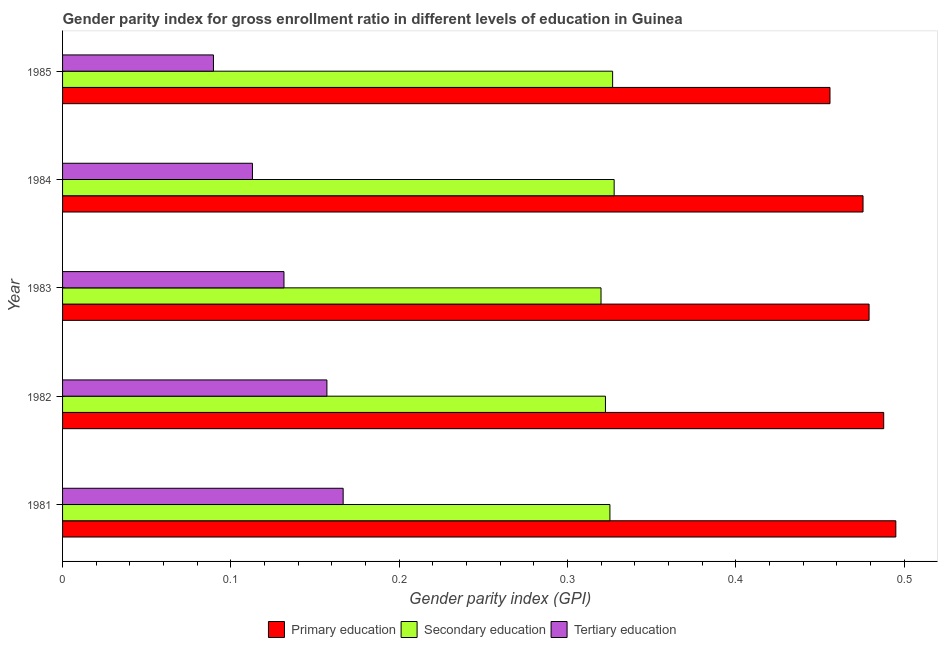How many groups of bars are there?
Offer a very short reply. 5. Are the number of bars per tick equal to the number of legend labels?
Your response must be concise. Yes. How many bars are there on the 3rd tick from the bottom?
Offer a very short reply. 3. In how many cases, is the number of bars for a given year not equal to the number of legend labels?
Give a very brief answer. 0. What is the gender parity index in secondary education in 1985?
Ensure brevity in your answer.  0.33. Across all years, what is the maximum gender parity index in secondary education?
Give a very brief answer. 0.33. Across all years, what is the minimum gender parity index in secondary education?
Provide a short and direct response. 0.32. In which year was the gender parity index in tertiary education maximum?
Offer a terse response. 1981. What is the total gender parity index in primary education in the graph?
Your response must be concise. 2.39. What is the difference between the gender parity index in primary education in 1981 and that in 1983?
Your response must be concise. 0.02. What is the difference between the gender parity index in tertiary education in 1984 and the gender parity index in primary education in 1981?
Provide a succinct answer. -0.38. What is the average gender parity index in secondary education per year?
Provide a succinct answer. 0.32. In the year 1983, what is the difference between the gender parity index in secondary education and gender parity index in tertiary education?
Offer a very short reply. 0.19. In how many years, is the gender parity index in primary education greater than 0.34 ?
Provide a succinct answer. 5. What is the ratio of the gender parity index in tertiary education in 1984 to that in 1985?
Make the answer very short. 1.26. Is the gender parity index in secondary education in 1982 less than that in 1984?
Provide a succinct answer. Yes. Is the difference between the gender parity index in secondary education in 1981 and 1982 greater than the difference between the gender parity index in primary education in 1981 and 1982?
Give a very brief answer. No. What is the difference between the highest and the second highest gender parity index in primary education?
Provide a succinct answer. 0.01. What is the difference between the highest and the lowest gender parity index in secondary education?
Provide a short and direct response. 0.01. In how many years, is the gender parity index in secondary education greater than the average gender parity index in secondary education taken over all years?
Your answer should be compact. 3. Is the sum of the gender parity index in tertiary education in 1981 and 1984 greater than the maximum gender parity index in primary education across all years?
Your response must be concise. No. What does the 1st bar from the top in 1984 represents?
Your answer should be very brief. Tertiary education. What does the 2nd bar from the bottom in 1984 represents?
Your answer should be compact. Secondary education. What is the difference between two consecutive major ticks on the X-axis?
Give a very brief answer. 0.1. Does the graph contain any zero values?
Your answer should be compact. No. Does the graph contain grids?
Make the answer very short. No. What is the title of the graph?
Make the answer very short. Gender parity index for gross enrollment ratio in different levels of education in Guinea. Does "Tertiary education" appear as one of the legend labels in the graph?
Your answer should be compact. Yes. What is the label or title of the X-axis?
Ensure brevity in your answer.  Gender parity index (GPI). What is the label or title of the Y-axis?
Make the answer very short. Year. What is the Gender parity index (GPI) in Primary education in 1981?
Provide a short and direct response. 0.49. What is the Gender parity index (GPI) in Secondary education in 1981?
Ensure brevity in your answer.  0.33. What is the Gender parity index (GPI) in Tertiary education in 1981?
Offer a terse response. 0.17. What is the Gender parity index (GPI) in Primary education in 1982?
Give a very brief answer. 0.49. What is the Gender parity index (GPI) of Secondary education in 1982?
Provide a short and direct response. 0.32. What is the Gender parity index (GPI) in Tertiary education in 1982?
Provide a short and direct response. 0.16. What is the Gender parity index (GPI) in Primary education in 1983?
Provide a succinct answer. 0.48. What is the Gender parity index (GPI) of Secondary education in 1983?
Your response must be concise. 0.32. What is the Gender parity index (GPI) in Tertiary education in 1983?
Your answer should be compact. 0.13. What is the Gender parity index (GPI) of Primary education in 1984?
Give a very brief answer. 0.48. What is the Gender parity index (GPI) in Secondary education in 1984?
Make the answer very short. 0.33. What is the Gender parity index (GPI) in Tertiary education in 1984?
Provide a succinct answer. 0.11. What is the Gender parity index (GPI) of Primary education in 1985?
Make the answer very short. 0.46. What is the Gender parity index (GPI) of Secondary education in 1985?
Your response must be concise. 0.33. What is the Gender parity index (GPI) of Tertiary education in 1985?
Give a very brief answer. 0.09. Across all years, what is the maximum Gender parity index (GPI) of Primary education?
Make the answer very short. 0.49. Across all years, what is the maximum Gender parity index (GPI) of Secondary education?
Give a very brief answer. 0.33. Across all years, what is the maximum Gender parity index (GPI) in Tertiary education?
Your answer should be compact. 0.17. Across all years, what is the minimum Gender parity index (GPI) in Primary education?
Your response must be concise. 0.46. Across all years, what is the minimum Gender parity index (GPI) of Secondary education?
Offer a terse response. 0.32. Across all years, what is the minimum Gender parity index (GPI) in Tertiary education?
Keep it short and to the point. 0.09. What is the total Gender parity index (GPI) in Primary education in the graph?
Your answer should be very brief. 2.39. What is the total Gender parity index (GPI) of Secondary education in the graph?
Provide a short and direct response. 1.62. What is the total Gender parity index (GPI) in Tertiary education in the graph?
Make the answer very short. 0.66. What is the difference between the Gender parity index (GPI) of Primary education in 1981 and that in 1982?
Your answer should be very brief. 0.01. What is the difference between the Gender parity index (GPI) of Secondary education in 1981 and that in 1982?
Ensure brevity in your answer.  0. What is the difference between the Gender parity index (GPI) of Tertiary education in 1981 and that in 1982?
Your response must be concise. 0.01. What is the difference between the Gender parity index (GPI) in Primary education in 1981 and that in 1983?
Make the answer very short. 0.02. What is the difference between the Gender parity index (GPI) in Secondary education in 1981 and that in 1983?
Your response must be concise. 0.01. What is the difference between the Gender parity index (GPI) in Tertiary education in 1981 and that in 1983?
Give a very brief answer. 0.04. What is the difference between the Gender parity index (GPI) in Primary education in 1981 and that in 1984?
Your response must be concise. 0.02. What is the difference between the Gender parity index (GPI) of Secondary education in 1981 and that in 1984?
Your response must be concise. -0. What is the difference between the Gender parity index (GPI) of Tertiary education in 1981 and that in 1984?
Offer a terse response. 0.05. What is the difference between the Gender parity index (GPI) in Primary education in 1981 and that in 1985?
Make the answer very short. 0.04. What is the difference between the Gender parity index (GPI) of Secondary education in 1981 and that in 1985?
Provide a succinct answer. -0. What is the difference between the Gender parity index (GPI) of Tertiary education in 1981 and that in 1985?
Offer a very short reply. 0.08. What is the difference between the Gender parity index (GPI) in Primary education in 1982 and that in 1983?
Provide a short and direct response. 0.01. What is the difference between the Gender parity index (GPI) in Secondary education in 1982 and that in 1983?
Your response must be concise. 0. What is the difference between the Gender parity index (GPI) of Tertiary education in 1982 and that in 1983?
Keep it short and to the point. 0.03. What is the difference between the Gender parity index (GPI) in Primary education in 1982 and that in 1984?
Make the answer very short. 0.01. What is the difference between the Gender parity index (GPI) in Secondary education in 1982 and that in 1984?
Provide a short and direct response. -0.01. What is the difference between the Gender parity index (GPI) of Tertiary education in 1982 and that in 1984?
Ensure brevity in your answer.  0.04. What is the difference between the Gender parity index (GPI) in Primary education in 1982 and that in 1985?
Provide a short and direct response. 0.03. What is the difference between the Gender parity index (GPI) of Secondary education in 1982 and that in 1985?
Provide a short and direct response. -0. What is the difference between the Gender parity index (GPI) of Tertiary education in 1982 and that in 1985?
Your answer should be very brief. 0.07. What is the difference between the Gender parity index (GPI) of Primary education in 1983 and that in 1984?
Offer a very short reply. 0. What is the difference between the Gender parity index (GPI) of Secondary education in 1983 and that in 1984?
Give a very brief answer. -0.01. What is the difference between the Gender parity index (GPI) of Tertiary education in 1983 and that in 1984?
Keep it short and to the point. 0.02. What is the difference between the Gender parity index (GPI) in Primary education in 1983 and that in 1985?
Provide a short and direct response. 0.02. What is the difference between the Gender parity index (GPI) in Secondary education in 1983 and that in 1985?
Offer a very short reply. -0.01. What is the difference between the Gender parity index (GPI) of Tertiary education in 1983 and that in 1985?
Provide a short and direct response. 0.04. What is the difference between the Gender parity index (GPI) in Primary education in 1984 and that in 1985?
Make the answer very short. 0.02. What is the difference between the Gender parity index (GPI) in Secondary education in 1984 and that in 1985?
Ensure brevity in your answer.  0. What is the difference between the Gender parity index (GPI) in Tertiary education in 1984 and that in 1985?
Ensure brevity in your answer.  0.02. What is the difference between the Gender parity index (GPI) in Primary education in 1981 and the Gender parity index (GPI) in Secondary education in 1982?
Ensure brevity in your answer.  0.17. What is the difference between the Gender parity index (GPI) in Primary education in 1981 and the Gender parity index (GPI) in Tertiary education in 1982?
Your answer should be compact. 0.34. What is the difference between the Gender parity index (GPI) of Secondary education in 1981 and the Gender parity index (GPI) of Tertiary education in 1982?
Keep it short and to the point. 0.17. What is the difference between the Gender parity index (GPI) of Primary education in 1981 and the Gender parity index (GPI) of Secondary education in 1983?
Keep it short and to the point. 0.18. What is the difference between the Gender parity index (GPI) of Primary education in 1981 and the Gender parity index (GPI) of Tertiary education in 1983?
Provide a short and direct response. 0.36. What is the difference between the Gender parity index (GPI) of Secondary education in 1981 and the Gender parity index (GPI) of Tertiary education in 1983?
Make the answer very short. 0.19. What is the difference between the Gender parity index (GPI) in Primary education in 1981 and the Gender parity index (GPI) in Secondary education in 1984?
Your response must be concise. 0.17. What is the difference between the Gender parity index (GPI) of Primary education in 1981 and the Gender parity index (GPI) of Tertiary education in 1984?
Keep it short and to the point. 0.38. What is the difference between the Gender parity index (GPI) of Secondary education in 1981 and the Gender parity index (GPI) of Tertiary education in 1984?
Your response must be concise. 0.21. What is the difference between the Gender parity index (GPI) in Primary education in 1981 and the Gender parity index (GPI) in Secondary education in 1985?
Ensure brevity in your answer.  0.17. What is the difference between the Gender parity index (GPI) of Primary education in 1981 and the Gender parity index (GPI) of Tertiary education in 1985?
Your answer should be very brief. 0.41. What is the difference between the Gender parity index (GPI) of Secondary education in 1981 and the Gender parity index (GPI) of Tertiary education in 1985?
Give a very brief answer. 0.24. What is the difference between the Gender parity index (GPI) of Primary education in 1982 and the Gender parity index (GPI) of Secondary education in 1983?
Offer a very short reply. 0.17. What is the difference between the Gender parity index (GPI) of Primary education in 1982 and the Gender parity index (GPI) of Tertiary education in 1983?
Your response must be concise. 0.36. What is the difference between the Gender parity index (GPI) of Secondary education in 1982 and the Gender parity index (GPI) of Tertiary education in 1983?
Give a very brief answer. 0.19. What is the difference between the Gender parity index (GPI) in Primary education in 1982 and the Gender parity index (GPI) in Secondary education in 1984?
Ensure brevity in your answer.  0.16. What is the difference between the Gender parity index (GPI) in Primary education in 1982 and the Gender parity index (GPI) in Tertiary education in 1984?
Provide a succinct answer. 0.38. What is the difference between the Gender parity index (GPI) of Secondary education in 1982 and the Gender parity index (GPI) of Tertiary education in 1984?
Offer a terse response. 0.21. What is the difference between the Gender parity index (GPI) of Primary education in 1982 and the Gender parity index (GPI) of Secondary education in 1985?
Give a very brief answer. 0.16. What is the difference between the Gender parity index (GPI) of Primary education in 1982 and the Gender parity index (GPI) of Tertiary education in 1985?
Your answer should be compact. 0.4. What is the difference between the Gender parity index (GPI) of Secondary education in 1982 and the Gender parity index (GPI) of Tertiary education in 1985?
Ensure brevity in your answer.  0.23. What is the difference between the Gender parity index (GPI) in Primary education in 1983 and the Gender parity index (GPI) in Secondary education in 1984?
Keep it short and to the point. 0.15. What is the difference between the Gender parity index (GPI) of Primary education in 1983 and the Gender parity index (GPI) of Tertiary education in 1984?
Your response must be concise. 0.37. What is the difference between the Gender parity index (GPI) in Secondary education in 1983 and the Gender parity index (GPI) in Tertiary education in 1984?
Your answer should be very brief. 0.21. What is the difference between the Gender parity index (GPI) in Primary education in 1983 and the Gender parity index (GPI) in Secondary education in 1985?
Your answer should be compact. 0.15. What is the difference between the Gender parity index (GPI) in Primary education in 1983 and the Gender parity index (GPI) in Tertiary education in 1985?
Give a very brief answer. 0.39. What is the difference between the Gender parity index (GPI) of Secondary education in 1983 and the Gender parity index (GPI) of Tertiary education in 1985?
Make the answer very short. 0.23. What is the difference between the Gender parity index (GPI) in Primary education in 1984 and the Gender parity index (GPI) in Secondary education in 1985?
Offer a terse response. 0.15. What is the difference between the Gender parity index (GPI) in Primary education in 1984 and the Gender parity index (GPI) in Tertiary education in 1985?
Offer a very short reply. 0.39. What is the difference between the Gender parity index (GPI) in Secondary education in 1984 and the Gender parity index (GPI) in Tertiary education in 1985?
Your response must be concise. 0.24. What is the average Gender parity index (GPI) of Primary education per year?
Your response must be concise. 0.48. What is the average Gender parity index (GPI) in Secondary education per year?
Keep it short and to the point. 0.32. What is the average Gender parity index (GPI) of Tertiary education per year?
Give a very brief answer. 0.13. In the year 1981, what is the difference between the Gender parity index (GPI) in Primary education and Gender parity index (GPI) in Secondary education?
Provide a succinct answer. 0.17. In the year 1981, what is the difference between the Gender parity index (GPI) of Primary education and Gender parity index (GPI) of Tertiary education?
Give a very brief answer. 0.33. In the year 1981, what is the difference between the Gender parity index (GPI) in Secondary education and Gender parity index (GPI) in Tertiary education?
Give a very brief answer. 0.16. In the year 1982, what is the difference between the Gender parity index (GPI) in Primary education and Gender parity index (GPI) in Secondary education?
Keep it short and to the point. 0.17. In the year 1982, what is the difference between the Gender parity index (GPI) of Primary education and Gender parity index (GPI) of Tertiary education?
Keep it short and to the point. 0.33. In the year 1982, what is the difference between the Gender parity index (GPI) of Secondary education and Gender parity index (GPI) of Tertiary education?
Your answer should be compact. 0.17. In the year 1983, what is the difference between the Gender parity index (GPI) in Primary education and Gender parity index (GPI) in Secondary education?
Give a very brief answer. 0.16. In the year 1983, what is the difference between the Gender parity index (GPI) of Primary education and Gender parity index (GPI) of Tertiary education?
Offer a terse response. 0.35. In the year 1983, what is the difference between the Gender parity index (GPI) of Secondary education and Gender parity index (GPI) of Tertiary education?
Offer a terse response. 0.19. In the year 1984, what is the difference between the Gender parity index (GPI) in Primary education and Gender parity index (GPI) in Secondary education?
Ensure brevity in your answer.  0.15. In the year 1984, what is the difference between the Gender parity index (GPI) in Primary education and Gender parity index (GPI) in Tertiary education?
Ensure brevity in your answer.  0.36. In the year 1984, what is the difference between the Gender parity index (GPI) of Secondary education and Gender parity index (GPI) of Tertiary education?
Provide a short and direct response. 0.21. In the year 1985, what is the difference between the Gender parity index (GPI) in Primary education and Gender parity index (GPI) in Secondary education?
Keep it short and to the point. 0.13. In the year 1985, what is the difference between the Gender parity index (GPI) of Primary education and Gender parity index (GPI) of Tertiary education?
Make the answer very short. 0.37. In the year 1985, what is the difference between the Gender parity index (GPI) in Secondary education and Gender parity index (GPI) in Tertiary education?
Your answer should be compact. 0.24. What is the ratio of the Gender parity index (GPI) in Primary education in 1981 to that in 1982?
Offer a terse response. 1.01. What is the ratio of the Gender parity index (GPI) in Secondary education in 1981 to that in 1982?
Make the answer very short. 1.01. What is the ratio of the Gender parity index (GPI) of Tertiary education in 1981 to that in 1982?
Offer a very short reply. 1.06. What is the ratio of the Gender parity index (GPI) of Primary education in 1981 to that in 1983?
Offer a terse response. 1.03. What is the ratio of the Gender parity index (GPI) in Secondary education in 1981 to that in 1983?
Offer a very short reply. 1.02. What is the ratio of the Gender parity index (GPI) in Tertiary education in 1981 to that in 1983?
Ensure brevity in your answer.  1.27. What is the ratio of the Gender parity index (GPI) in Primary education in 1981 to that in 1984?
Your answer should be very brief. 1.04. What is the ratio of the Gender parity index (GPI) in Tertiary education in 1981 to that in 1984?
Provide a short and direct response. 1.48. What is the ratio of the Gender parity index (GPI) of Primary education in 1981 to that in 1985?
Your answer should be compact. 1.09. What is the ratio of the Gender parity index (GPI) of Tertiary education in 1981 to that in 1985?
Keep it short and to the point. 1.86. What is the ratio of the Gender parity index (GPI) in Primary education in 1982 to that in 1983?
Provide a short and direct response. 1.02. What is the ratio of the Gender parity index (GPI) in Secondary education in 1982 to that in 1983?
Your answer should be compact. 1.01. What is the ratio of the Gender parity index (GPI) of Tertiary education in 1982 to that in 1983?
Provide a succinct answer. 1.19. What is the ratio of the Gender parity index (GPI) of Primary education in 1982 to that in 1984?
Make the answer very short. 1.03. What is the ratio of the Gender parity index (GPI) of Secondary education in 1982 to that in 1984?
Provide a succinct answer. 0.98. What is the ratio of the Gender parity index (GPI) of Tertiary education in 1982 to that in 1984?
Provide a short and direct response. 1.39. What is the ratio of the Gender parity index (GPI) of Primary education in 1982 to that in 1985?
Your answer should be very brief. 1.07. What is the ratio of the Gender parity index (GPI) in Secondary education in 1982 to that in 1985?
Your answer should be compact. 0.99. What is the ratio of the Gender parity index (GPI) of Tertiary education in 1982 to that in 1985?
Provide a short and direct response. 1.75. What is the ratio of the Gender parity index (GPI) of Primary education in 1983 to that in 1984?
Offer a very short reply. 1.01. What is the ratio of the Gender parity index (GPI) of Secondary education in 1983 to that in 1984?
Provide a short and direct response. 0.98. What is the ratio of the Gender parity index (GPI) in Tertiary education in 1983 to that in 1984?
Your response must be concise. 1.17. What is the ratio of the Gender parity index (GPI) of Primary education in 1983 to that in 1985?
Your answer should be compact. 1.05. What is the ratio of the Gender parity index (GPI) in Secondary education in 1983 to that in 1985?
Your response must be concise. 0.98. What is the ratio of the Gender parity index (GPI) in Tertiary education in 1983 to that in 1985?
Your answer should be very brief. 1.47. What is the ratio of the Gender parity index (GPI) of Primary education in 1984 to that in 1985?
Offer a terse response. 1.04. What is the ratio of the Gender parity index (GPI) of Secondary education in 1984 to that in 1985?
Give a very brief answer. 1. What is the ratio of the Gender parity index (GPI) in Tertiary education in 1984 to that in 1985?
Make the answer very short. 1.26. What is the difference between the highest and the second highest Gender parity index (GPI) in Primary education?
Make the answer very short. 0.01. What is the difference between the highest and the second highest Gender parity index (GPI) in Secondary education?
Your answer should be compact. 0. What is the difference between the highest and the second highest Gender parity index (GPI) in Tertiary education?
Your response must be concise. 0.01. What is the difference between the highest and the lowest Gender parity index (GPI) of Primary education?
Provide a short and direct response. 0.04. What is the difference between the highest and the lowest Gender parity index (GPI) in Secondary education?
Provide a succinct answer. 0.01. What is the difference between the highest and the lowest Gender parity index (GPI) of Tertiary education?
Ensure brevity in your answer.  0.08. 